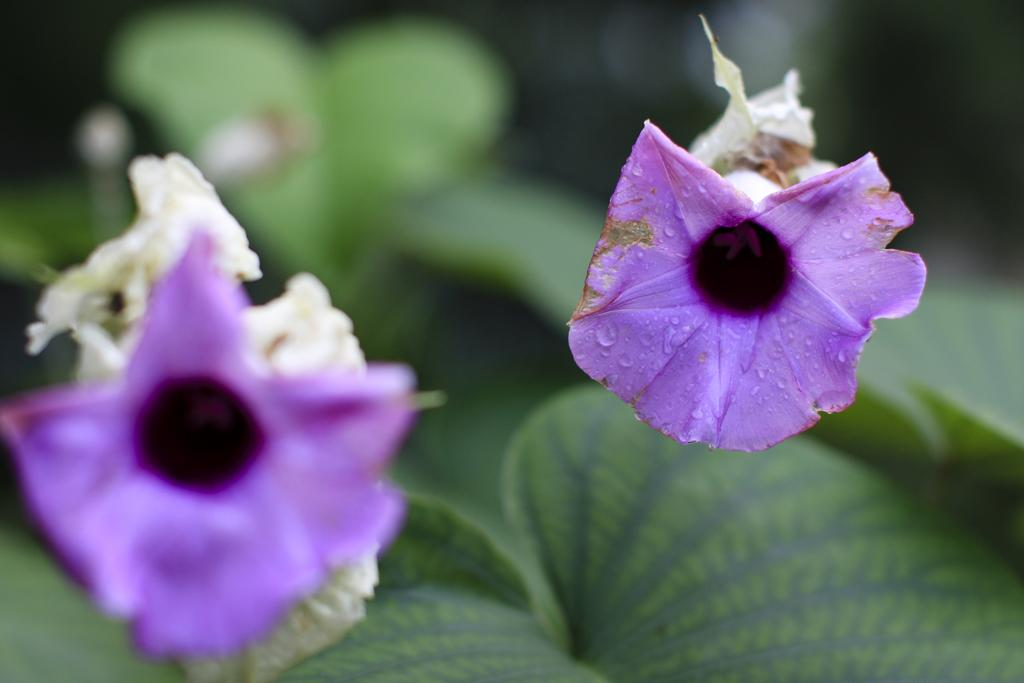What type of plant life is visible in the image? There are flowers and leaves in the image. Can you describe the background of the image? The background of the image is blurry. What type of brass instrument can be seen in the image? There is no brass instrument present in the image; it features flowers and leaves with a blurry background. 